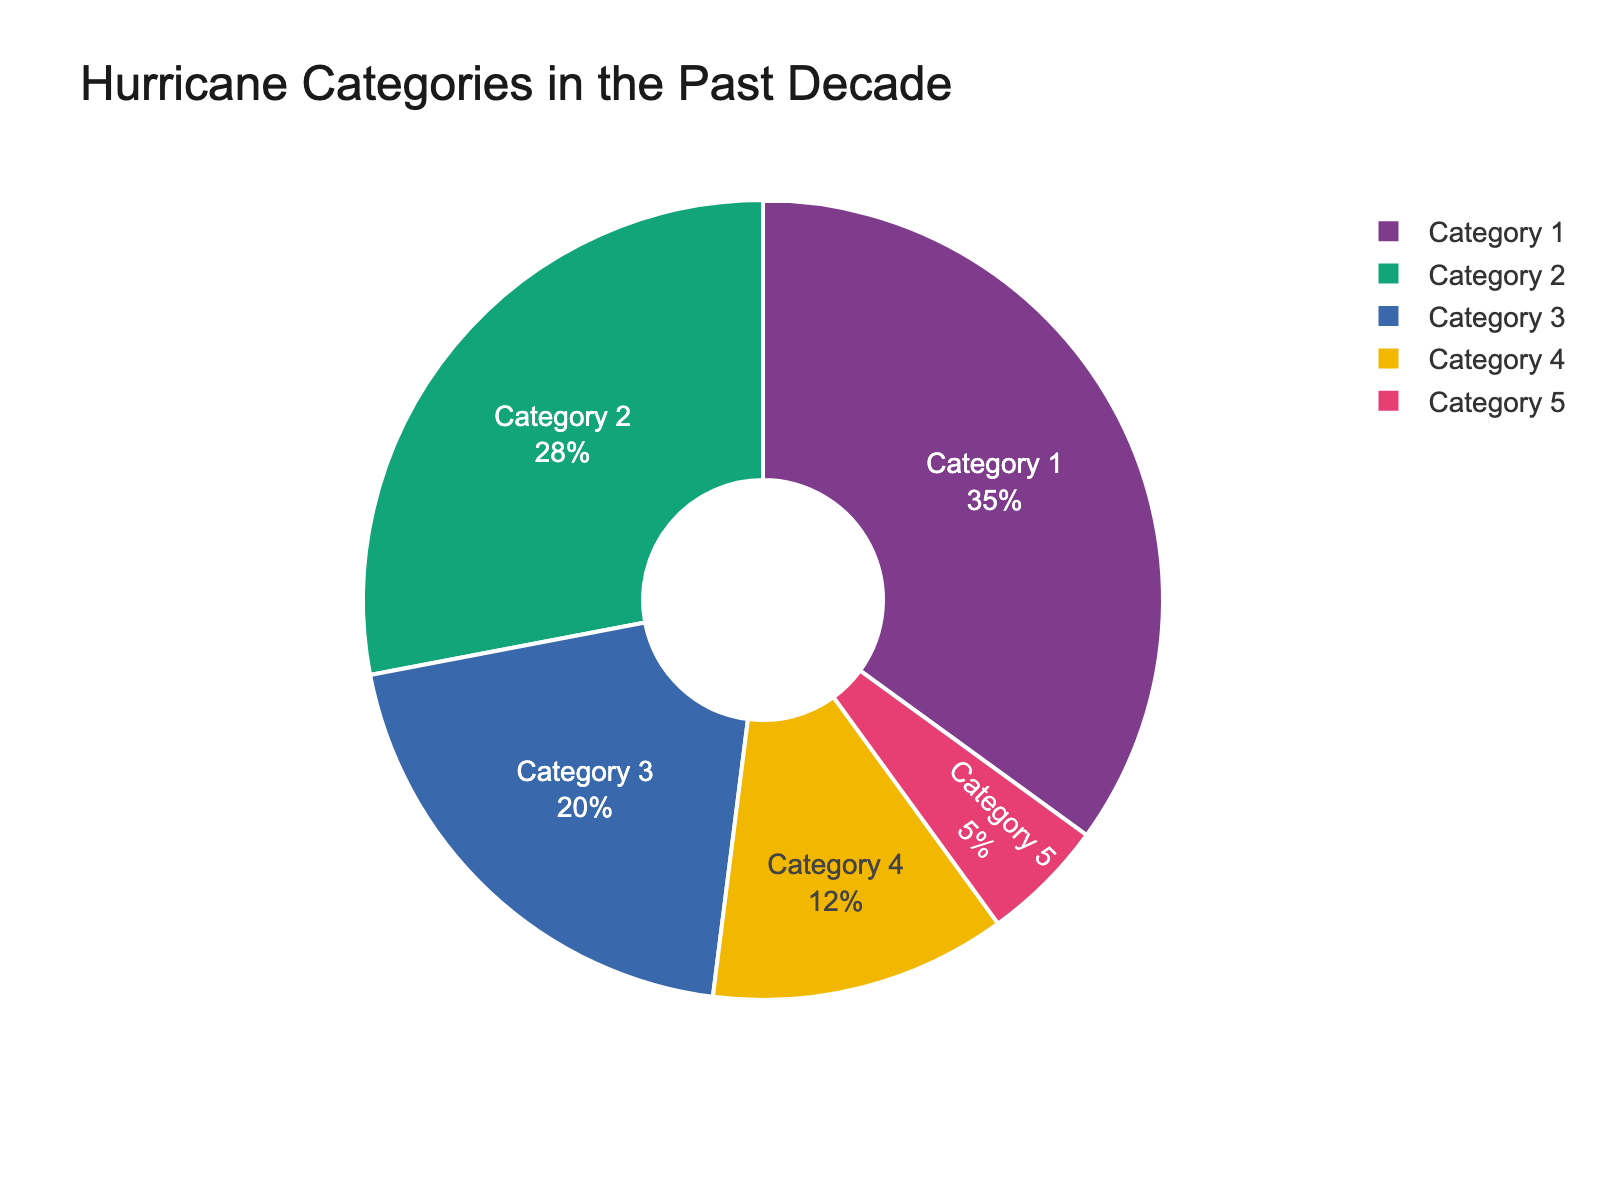What category of hurricanes has the highest percentage? The pie chart shows the largest section, which represents Category 1 hurricanes at 35%.
Answer: Category 1 What category of hurricanes has the smallest percentage? The smallest section of the pie chart represents Category 5 hurricanes with a 5% share.
Answer: Category 5 What is the total percentage of Category 2 and Category 3 hurricanes combined? By adding the percentages of Category 2 (28%) and Category 3 (20%) hurricanes, we get 28 + 20 = 48%.
Answer: 48% Which category has a higher percentage, Category 2 or Category 4? The pie chart indicates that Category 2 hurricanes have a higher percentage (28%) compared to Category 4 hurricanes (12%).
Answer: Category 2 How much larger is the percentage of Category 1 hurricanes compared to Category 5 hurricanes? Subtract the percentage of Category 5 hurricanes (5%) from Category 1 hurricanes (35%) to find the difference: 35 - 5 = 30%.
Answer: 30% If you wanted to determine roughly what fraction of hurricanes are either Category 1 or Category 4, what would it be? Adding the percentages of Category 1 (35%) and Category 4 (12%) hurricanes gives us 35 + 12 = 47%. In fraction form, 47% is about 47/100.
Answer: 47/100 What is the combined percentage of the most common and least common hurricane categories? The most common is Category 1 (35%), and the least common is Category 5 (5%). Adding them gives: 35 + 5 = 40%.
Answer: 40% Which two categories combined account for more than half of all hurricanes? Adding the percentages for Category 1 (35%) and Category 2 (28%) gives us 35 + 28 = 63%, which is more than half.
Answer: Category 1 and Category 2 What is the difference in percentage between Category 3 and Category 4 hurricanes? Subtract the percentage of Category 4 hurricanes (12%) from Category 3 hurricanes (20%) to get the difference: 20 - 12 = 8%.
Answer: 8% What is the average percentage of Category 2, 3, and 4 hurricanes? Sum the percentages of Category 2 (28%), Category 3 (20%), and Category 4 (12%) and divide by 3: (28 + 20 + 12) / 3 = 60 / 3 = 20%.
Answer: 20% 